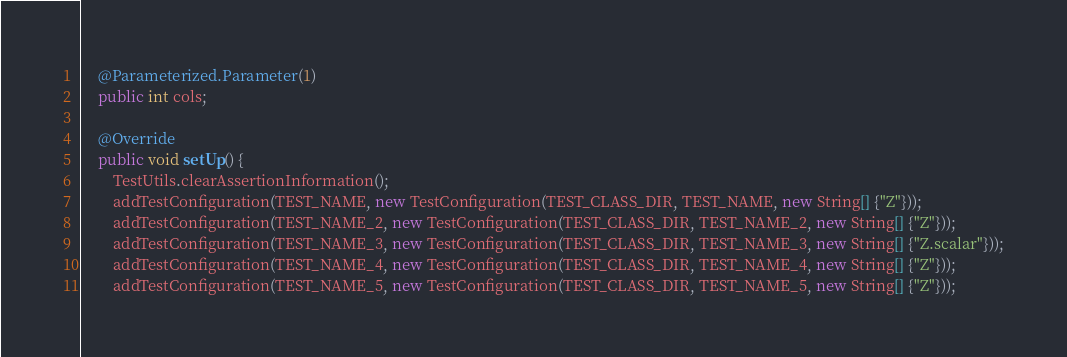<code> <loc_0><loc_0><loc_500><loc_500><_Java_>	@Parameterized.Parameter(1)
	public int cols;

	@Override
	public void setUp() {
		TestUtils.clearAssertionInformation();
		addTestConfiguration(TEST_NAME, new TestConfiguration(TEST_CLASS_DIR, TEST_NAME, new String[] {"Z"}));
		addTestConfiguration(TEST_NAME_2, new TestConfiguration(TEST_CLASS_DIR, TEST_NAME_2, new String[] {"Z"}));
		addTestConfiguration(TEST_NAME_3, new TestConfiguration(TEST_CLASS_DIR, TEST_NAME_3, new String[] {"Z.scalar"}));
		addTestConfiguration(TEST_NAME_4, new TestConfiguration(TEST_CLASS_DIR, TEST_NAME_4, new String[] {"Z"}));
		addTestConfiguration(TEST_NAME_5, new TestConfiguration(TEST_CLASS_DIR, TEST_NAME_5, new String[] {"Z"}));</code> 